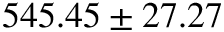Convert formula to latex. <formula><loc_0><loc_0><loc_500><loc_500>5 4 5 . 4 5 \pm 2 7 . 2 7</formula> 